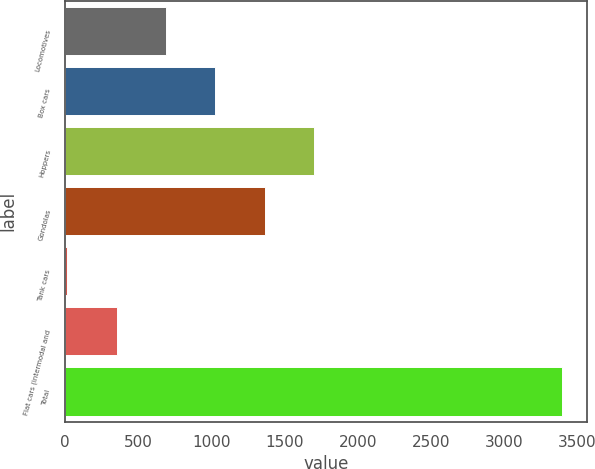<chart> <loc_0><loc_0><loc_500><loc_500><bar_chart><fcel>Locomotives<fcel>Box cars<fcel>Hoppers<fcel>Gondolas<fcel>Tank cars<fcel>Flat cars (intermodal and<fcel>Total<nl><fcel>690.8<fcel>1028.7<fcel>1704.5<fcel>1366.6<fcel>15<fcel>352.9<fcel>3394<nl></chart> 